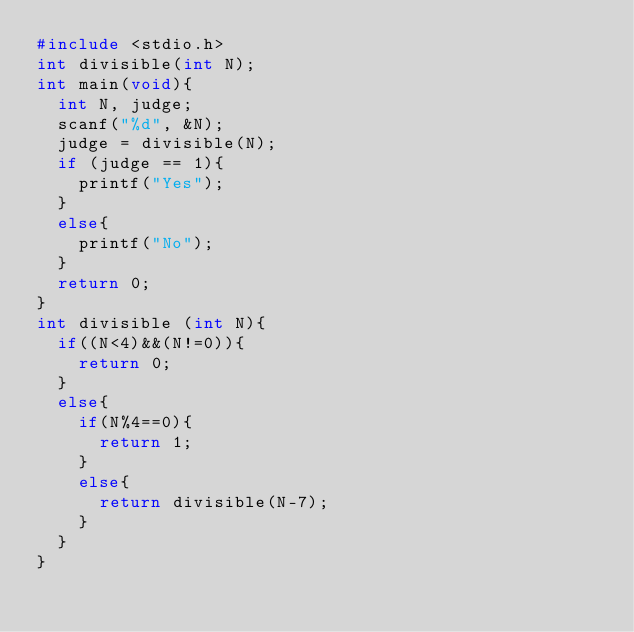Convert code to text. <code><loc_0><loc_0><loc_500><loc_500><_C_>#include <stdio.h>
int divisible(int N);
int main(void){
  int N, judge;
  scanf("%d", &N);
  judge = divisible(N);
  if (judge == 1){
    printf("Yes");
  }
  else{
    printf("No");
  }
  return 0;
}
int divisible (int N){
  if((N<4)&&(N!=0)){
    return 0;
  }
  else{
    if(N%4==0){
      return 1;
    }
    else{
      return divisible(N-7);
    }
  }
}
</code> 